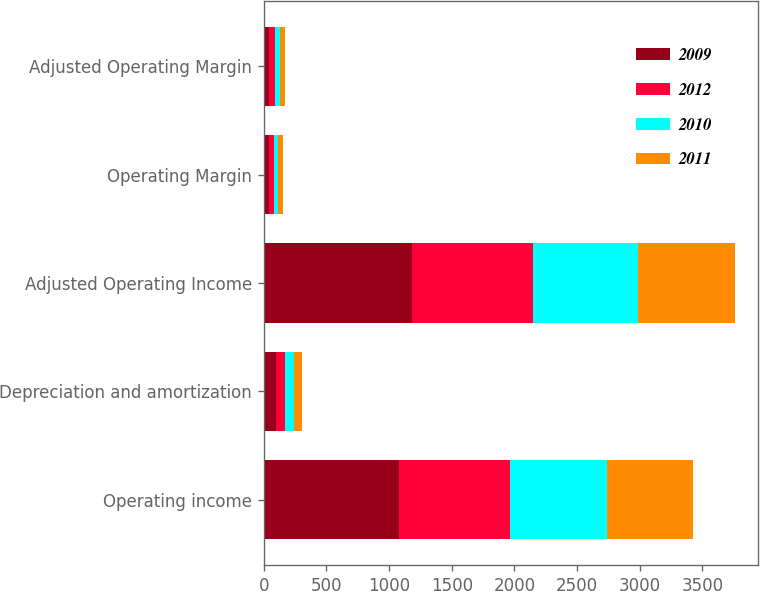<chart> <loc_0><loc_0><loc_500><loc_500><stacked_bar_chart><ecel><fcel>Operating income<fcel>Depreciation and amortization<fcel>Adjusted Operating Income<fcel>Operating Margin<fcel>Adjusted Operating Margin<nl><fcel>2009<fcel>1077.4<fcel>93.5<fcel>1183.1<fcel>39.5<fcel>43.3<nl><fcel>2012<fcel>888.4<fcel>79.2<fcel>967.6<fcel>39<fcel>42.4<nl><fcel>2010<fcel>772.8<fcel>66.3<fcel>839.2<fcel>38<fcel>41.3<nl><fcel>2011<fcel>687.5<fcel>64.1<fcel>769.1<fcel>38.3<fcel>42.8<nl></chart> 